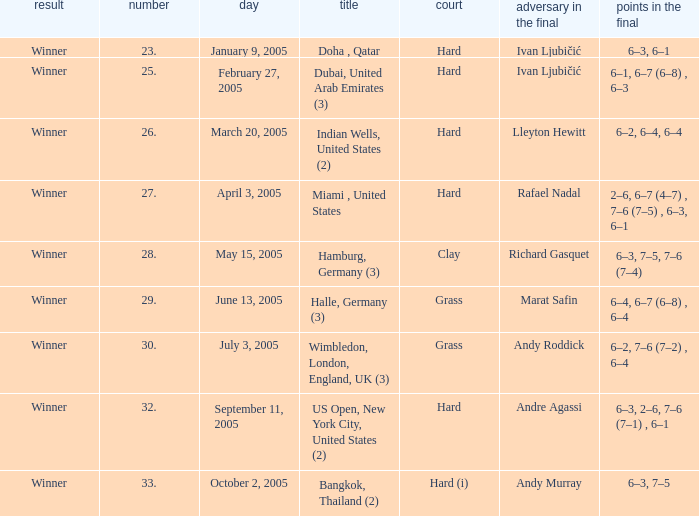In the championship Indian Wells, United States (2), who are the opponents in the final? Lleyton Hewitt. 